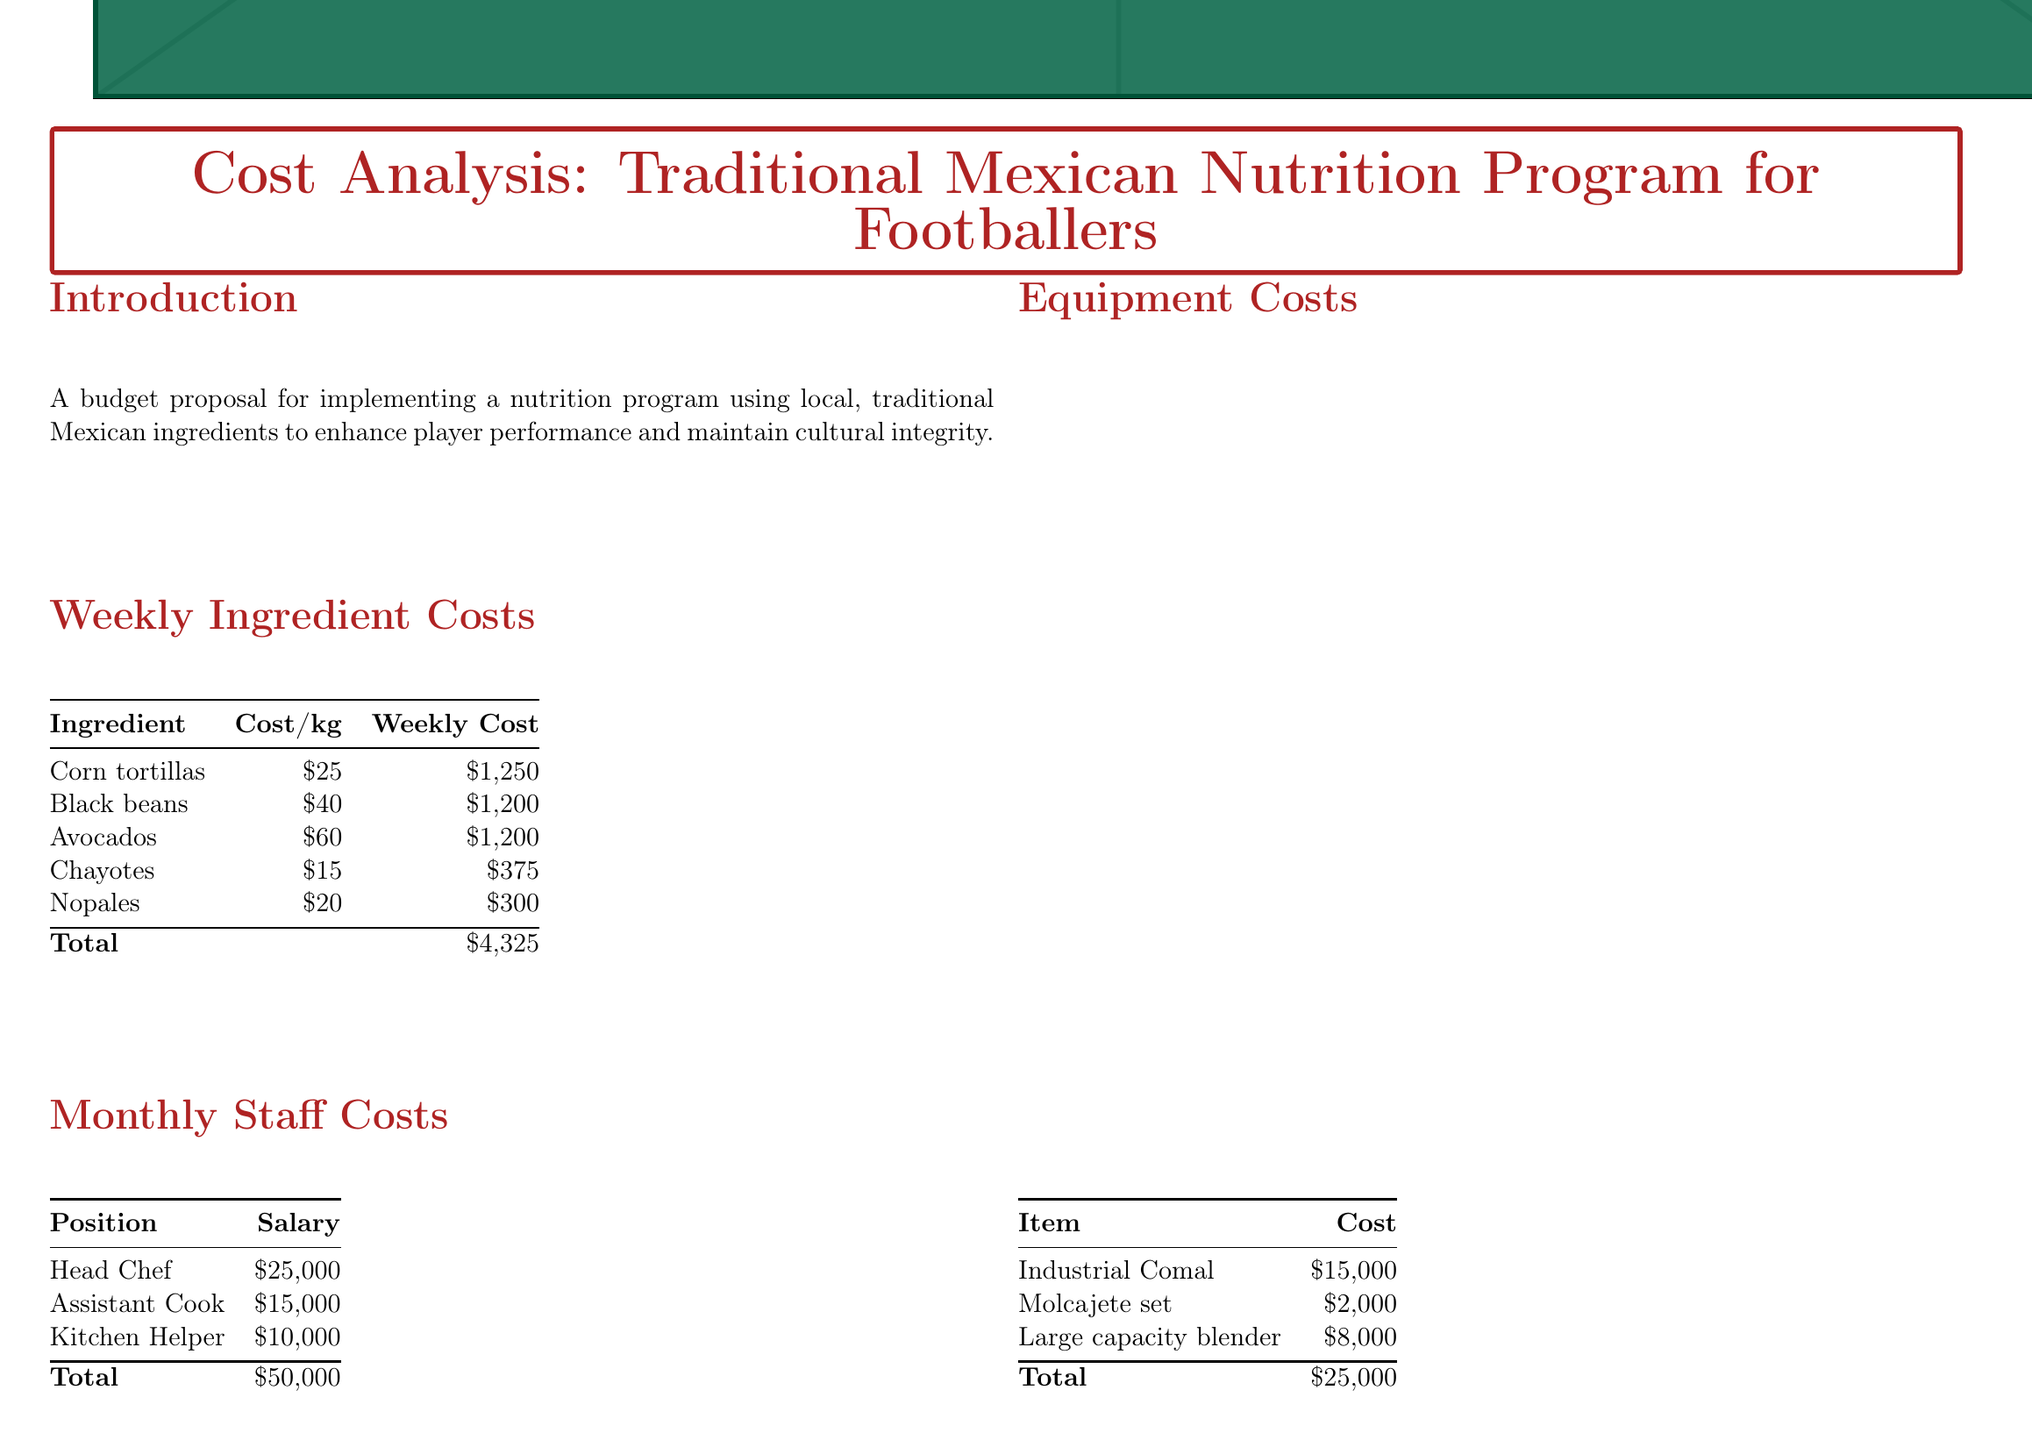what is the weekly cost of corn tortillas? The weekly cost of corn tortillas is listed in the document under "Weekly Ingredient Costs."
Answer: $1,250 what is the total monthly budget? The total monthly budget is summarized in the "Monthly Budget Summary" section of the document.
Answer: $71,383 what is the salary of the Head Chef? The salary of the Head Chef is provided in the "Monthly Staff Costs" section.
Answer: $25,000 how much can be saved monthly from Mercado de la Merced? The savings from Mercado de la Merced is noted under "Monthly Savings from Local Partnerships."
Answer: $5,000 what is the cost of the industrial comal? The cost of the industrial comal is mentioned in the "Equipment Costs" section.
Answer: $15,000 what are the expected benefits of the nutrition program? The document lists the expected benefits in a bullet point format under "Expected Benefits."
Answer: Improved player performance through familiar, nutrient-rich foods how much is spent on nutritionist consultation per month? The monthly cost for nutritionist consultation is detailed in the "Additional Monthly Costs" section.
Answer: $10,000 what is the total cost for black beans weekly? The total cost for black beans is specified in the "Weekly Ingredient Costs" table.
Answer: $1,200 